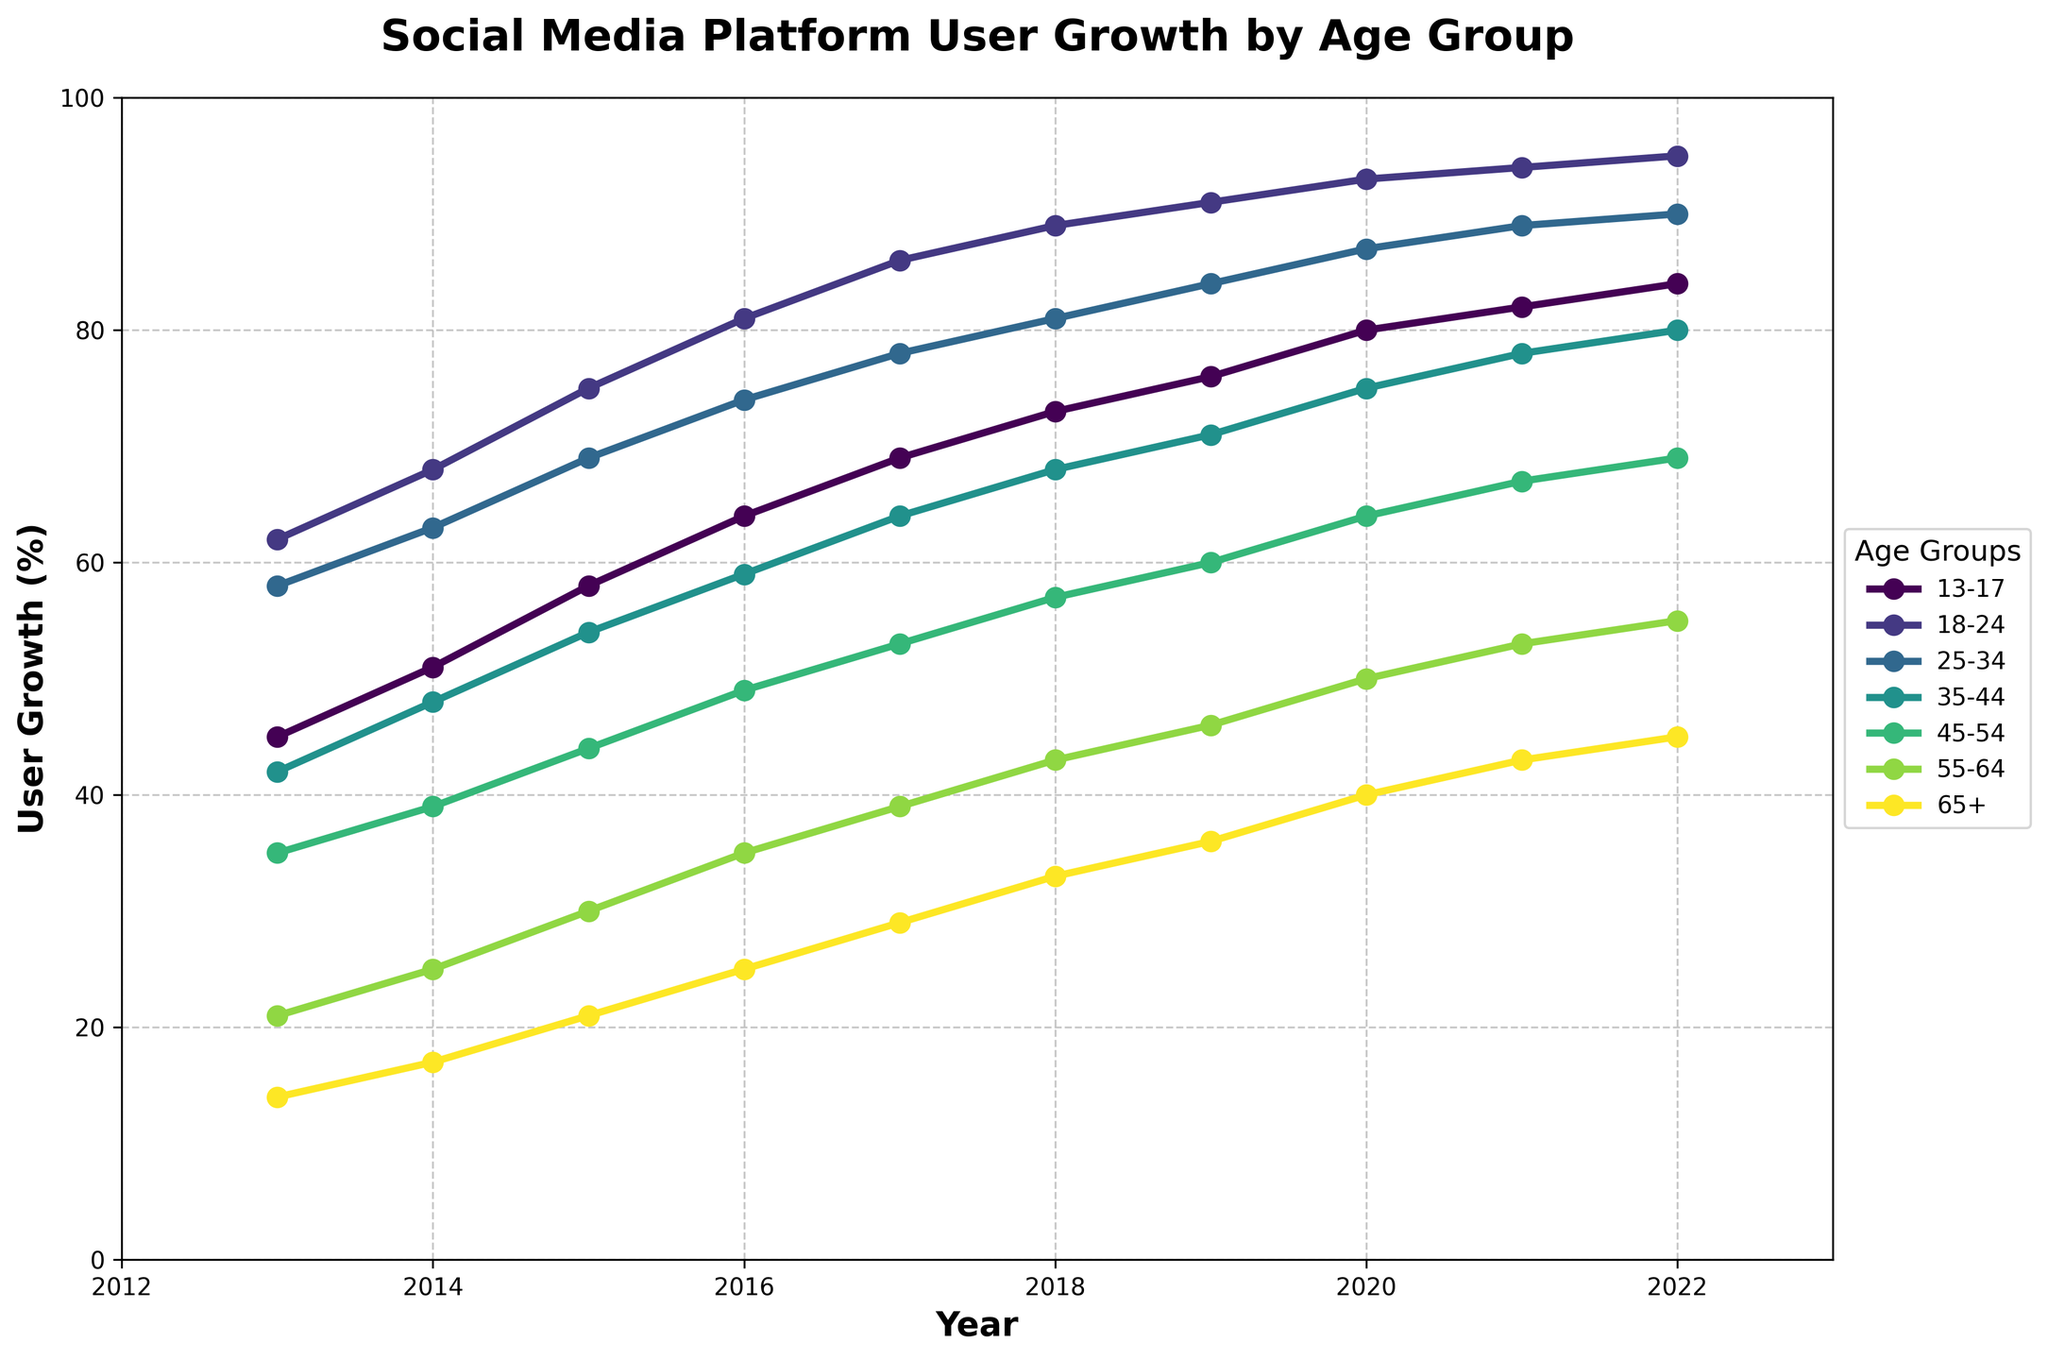What's the overall trend for social media user growth in the 18-24 age group from 2013 to 2022? The 18-24 age group shows a consistent increase in social media user growth over the years. Starting from 62% in 2013, the user growth rises incrementally each year, reaching 95% in 2022. This indicates a steady and significant increase in social media usage among this age group.
Answer: Consistent increase Which age group had the highest user growth percentage in 2022? To determine the age group with the highest user growth percentage in 2022, look at the '2022' column and compare the values across all age groups. The 18-24 age group has the highest percentage user growth at 95%.
Answer: 18-24 Did any age group's user growth decrease at any point between 2013 and 2022? Observing the lines for each age group between 2013 and 2022, none of the age groups dropped at any point. All age groups show a steady increase in user growth over the given period.
Answer: No Which age group had the slowest growth in social media usage between 2013 and 2022? To find the age group with the slowest growth, calculate the difference between the 2022 and 2013 values for each age group. The 65+ group increased from 14% in 2013 to 45% in 2022, a total growth of 31%, which is the lowest among all age groups.
Answer: 65+ By how much did the user growth percentage for the 25-34 age group increase from 2013 to 2022? Subtract the 2013 value of the 25-34 age group (58%) from its 2022 value (90%). The increase in user growth is 90% - 58% = 32%.
Answer: 32% Which age group showed the most significant growth trend visually on the chart? The most significant growth trend visually can be identified by the steepest slope. The 13-17 age group shows a steep incline from 45% in 2013 to 84% in 2022, indicating a rapid increase in user growth.
Answer: 13-17 What was the user growth percentage for the 35-44 age group in 2017? Locate the 2017 column and find the corresponding value for the 35-44 age group, which is 64%.
Answer: 64% Which age groups exceeded 70% user growth by 2022? By looking at the 2022 column, we see that the 13-17, 18-24, 25-34, 35-44, and 45-54 age groups all exceeded 70% user growth.
Answer: 13-17, 18-24, 25-34, 35-44, 45-54 